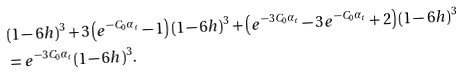Convert formula to latex. <formula><loc_0><loc_0><loc_500><loc_500>& ( 1 - 6 h ) ^ { 3 } + 3 \left ( e ^ { - C _ { 0 } \alpha _ { t } } - 1 \right ) ( 1 - 6 h ) ^ { 3 } + \left ( e ^ { - 3 C _ { 0 } \alpha _ { t } } - 3 e ^ { - C _ { 0 } \alpha _ { t } } + 2 \right ) ( 1 - 6 h ) ^ { 3 } \\ & = e ^ { - 3 C _ { 0 } \alpha _ { t } } ( 1 - 6 h ) ^ { 3 } .</formula> 